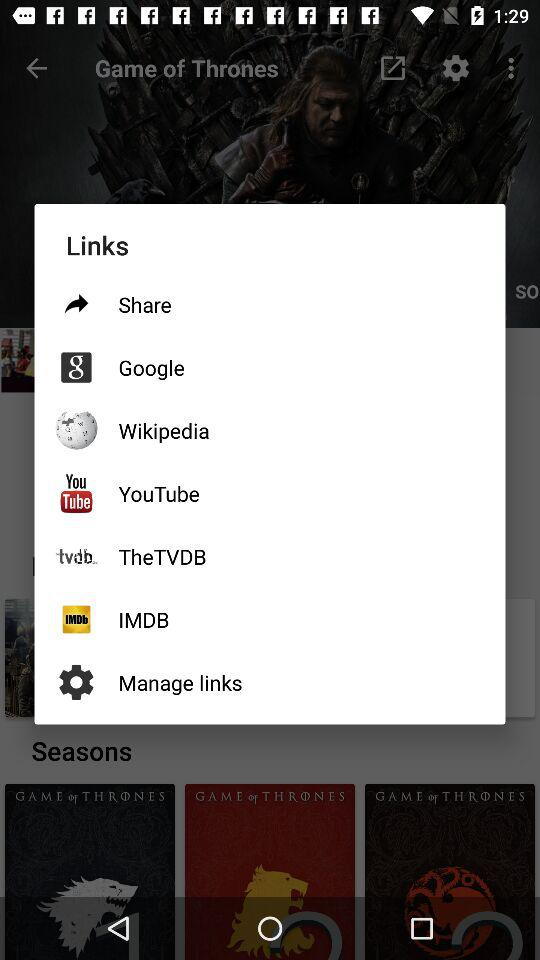Which application links are given? The given application links are "Share", "Google", "Wikipedia", "YouTube", "TheTVDB" and "IMDB". 